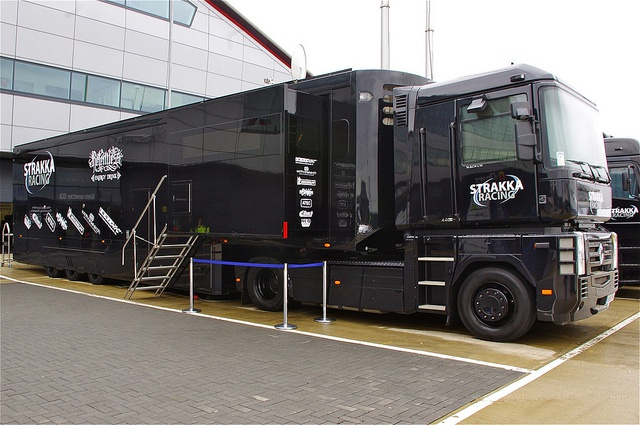Describe the objects in this image and their specific colors. I can see a truck in white, black, gray, lightgray, and darkgray tones in this image. 